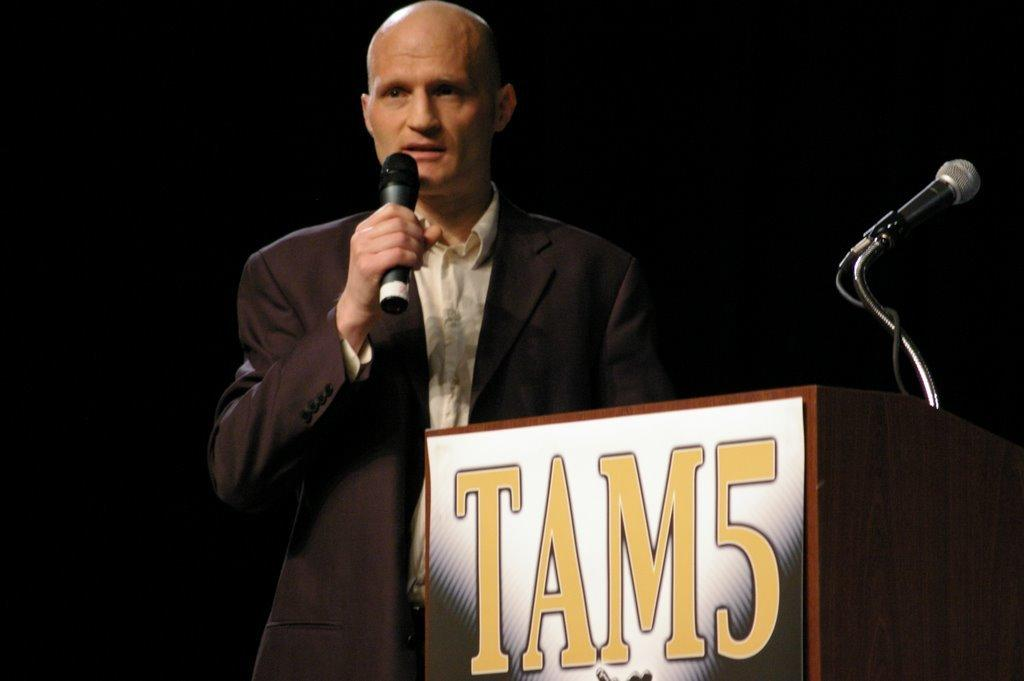Who is present in the image? There is a man in the image. What is the man doing in the image? The man is standing in the image. What object is the man holding in his hand? The man is holding a microphone in his hand. What can be seen near the man in the image? There is a podium in the image. What is on the podium in the image? There is a microphone on the podium. What word is written on the map in the image? There is no map present in the image, so it is not possible to answer that question. 